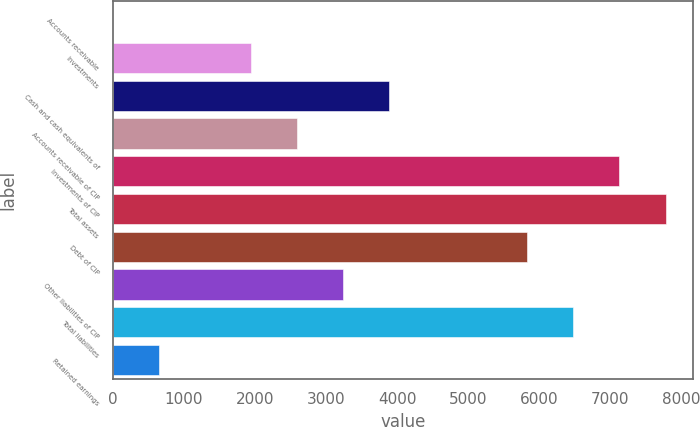Convert chart. <chart><loc_0><loc_0><loc_500><loc_500><bar_chart><fcel>Accounts receivable<fcel>Investments<fcel>Cash and cash equivalents of<fcel>Accounts receivable of CIP<fcel>Investments of CIP<fcel>Total assets<fcel>Debt of CIP<fcel>Other liabilities of CIP<fcel>Total liabilities<fcel>Retained earnings<nl><fcel>4.9<fcel>1947.28<fcel>3889.66<fcel>2594.74<fcel>7126.96<fcel>7774.42<fcel>5832.04<fcel>3242.2<fcel>6479.5<fcel>652.36<nl></chart> 